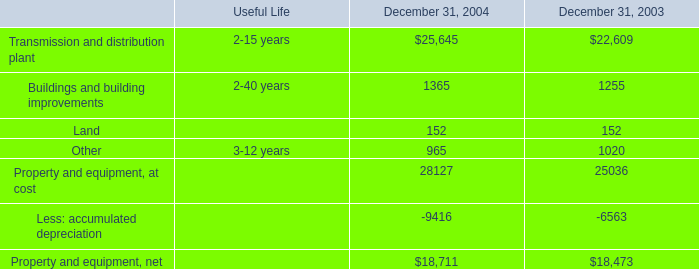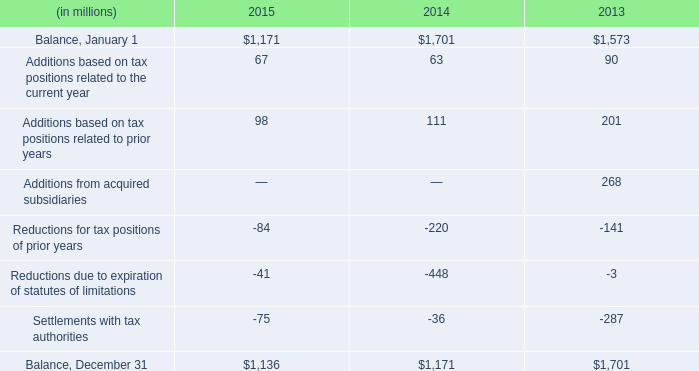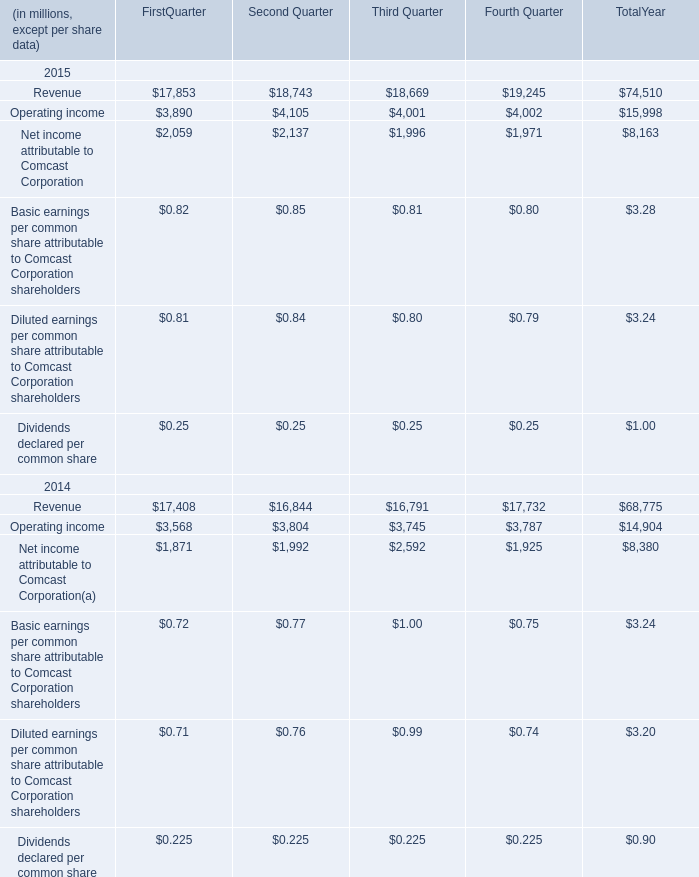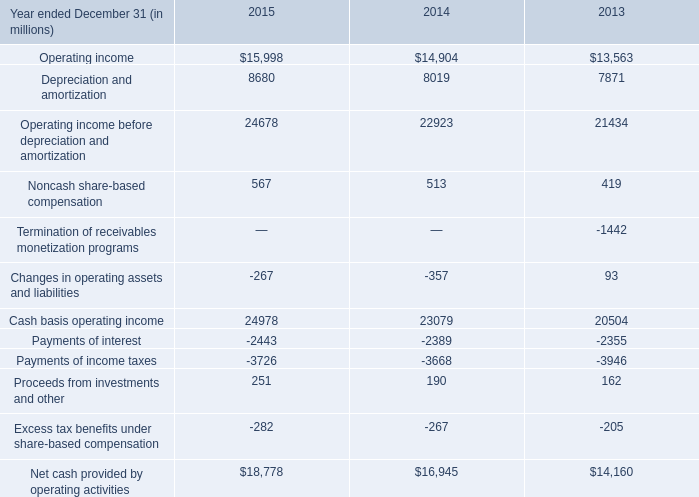What is the sum of Cash basis operating income of 2014, and Buildings and building improvements of December 31, 2004 ? 
Computations: (23079.0 + 1365.0)
Answer: 24444.0. 